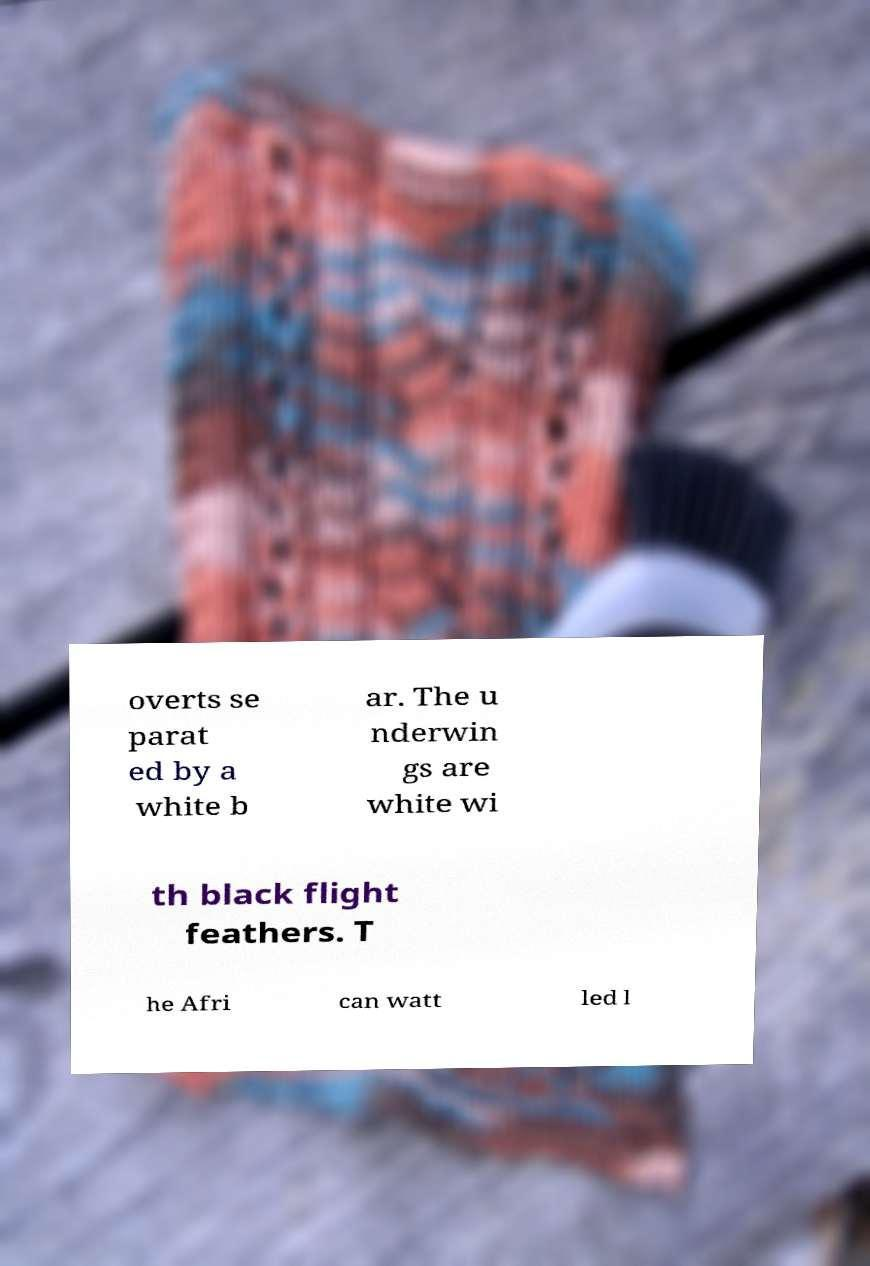There's text embedded in this image that I need extracted. Can you transcribe it verbatim? overts se parat ed by a white b ar. The u nderwin gs are white wi th black flight feathers. T he Afri can watt led l 